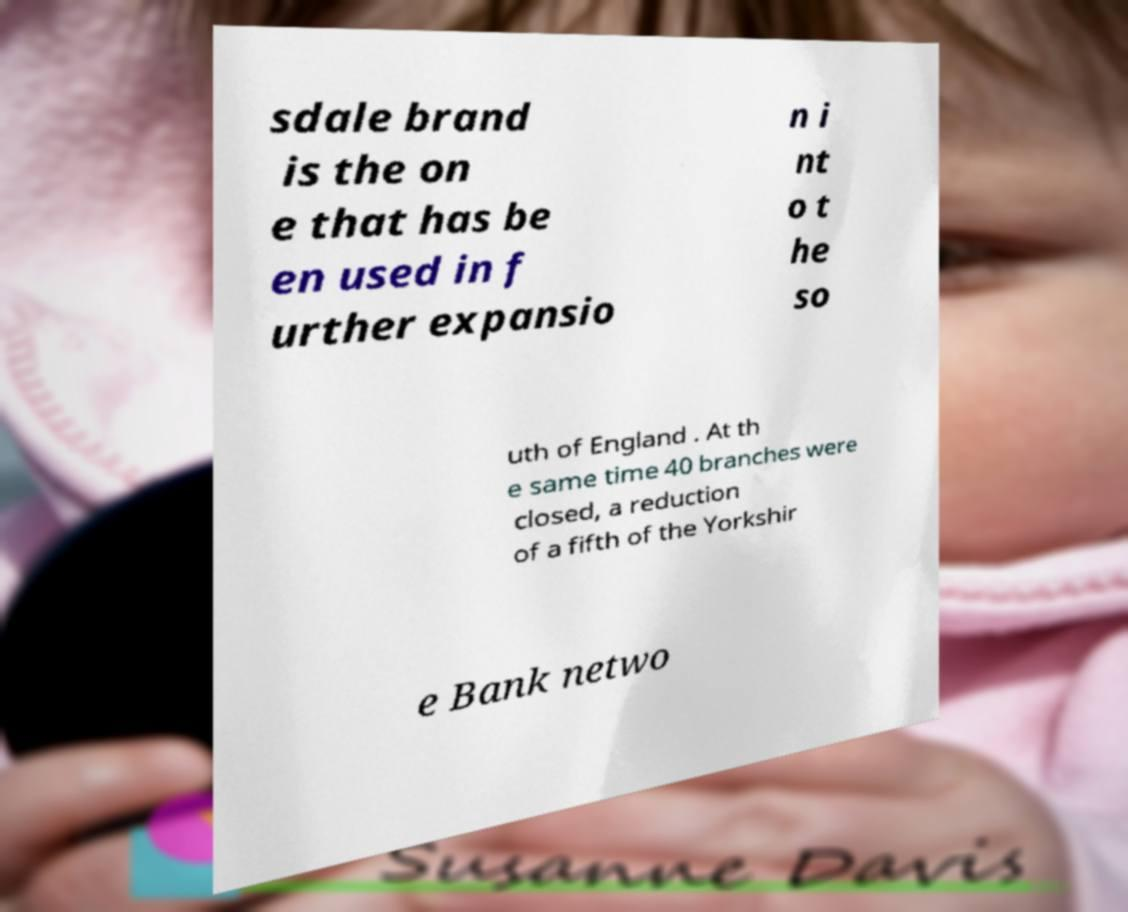Can you accurately transcribe the text from the provided image for me? sdale brand is the on e that has be en used in f urther expansio n i nt o t he so uth of England . At th e same time 40 branches were closed, a reduction of a fifth of the Yorkshir e Bank netwo 